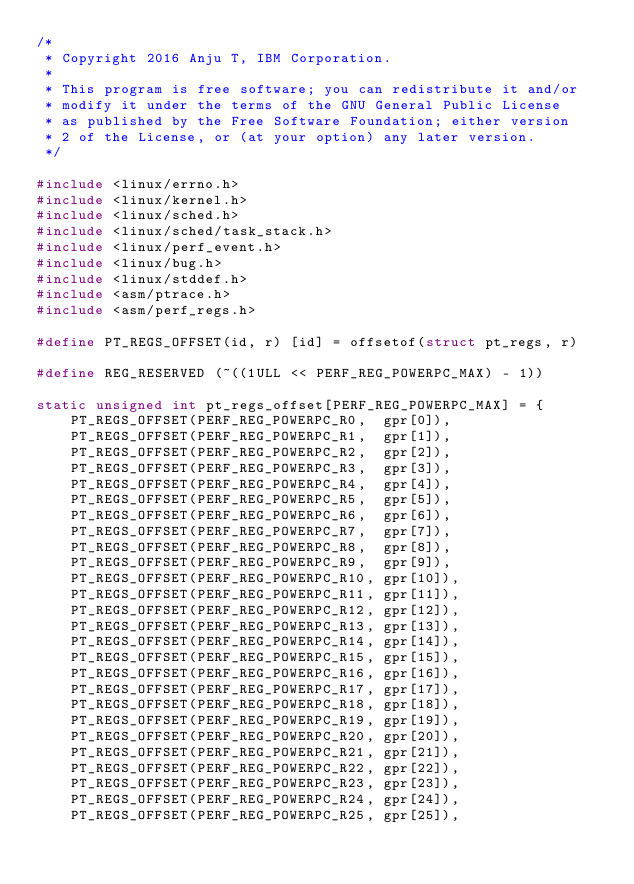Convert code to text. <code><loc_0><loc_0><loc_500><loc_500><_C_>/*
 * Copyright 2016 Anju T, IBM Corporation.
 *
 * This program is free software; you can redistribute it and/or
 * modify it under the terms of the GNU General Public License
 * as published by the Free Software Foundation; either version
 * 2 of the License, or (at your option) any later version.
 */

#include <linux/errno.h>
#include <linux/kernel.h>
#include <linux/sched.h>
#include <linux/sched/task_stack.h>
#include <linux/perf_event.h>
#include <linux/bug.h>
#include <linux/stddef.h>
#include <asm/ptrace.h>
#include <asm/perf_regs.h>

#define PT_REGS_OFFSET(id, r) [id] = offsetof(struct pt_regs, r)

#define REG_RESERVED (~((1ULL << PERF_REG_POWERPC_MAX) - 1))

static unsigned int pt_regs_offset[PERF_REG_POWERPC_MAX] = {
	PT_REGS_OFFSET(PERF_REG_POWERPC_R0,  gpr[0]),
	PT_REGS_OFFSET(PERF_REG_POWERPC_R1,  gpr[1]),
	PT_REGS_OFFSET(PERF_REG_POWERPC_R2,  gpr[2]),
	PT_REGS_OFFSET(PERF_REG_POWERPC_R3,  gpr[3]),
	PT_REGS_OFFSET(PERF_REG_POWERPC_R4,  gpr[4]),
	PT_REGS_OFFSET(PERF_REG_POWERPC_R5,  gpr[5]),
	PT_REGS_OFFSET(PERF_REG_POWERPC_R6,  gpr[6]),
	PT_REGS_OFFSET(PERF_REG_POWERPC_R7,  gpr[7]),
	PT_REGS_OFFSET(PERF_REG_POWERPC_R8,  gpr[8]),
	PT_REGS_OFFSET(PERF_REG_POWERPC_R9,  gpr[9]),
	PT_REGS_OFFSET(PERF_REG_POWERPC_R10, gpr[10]),
	PT_REGS_OFFSET(PERF_REG_POWERPC_R11, gpr[11]),
	PT_REGS_OFFSET(PERF_REG_POWERPC_R12, gpr[12]),
	PT_REGS_OFFSET(PERF_REG_POWERPC_R13, gpr[13]),
	PT_REGS_OFFSET(PERF_REG_POWERPC_R14, gpr[14]),
	PT_REGS_OFFSET(PERF_REG_POWERPC_R15, gpr[15]),
	PT_REGS_OFFSET(PERF_REG_POWERPC_R16, gpr[16]),
	PT_REGS_OFFSET(PERF_REG_POWERPC_R17, gpr[17]),
	PT_REGS_OFFSET(PERF_REG_POWERPC_R18, gpr[18]),
	PT_REGS_OFFSET(PERF_REG_POWERPC_R19, gpr[19]),
	PT_REGS_OFFSET(PERF_REG_POWERPC_R20, gpr[20]),
	PT_REGS_OFFSET(PERF_REG_POWERPC_R21, gpr[21]),
	PT_REGS_OFFSET(PERF_REG_POWERPC_R22, gpr[22]),
	PT_REGS_OFFSET(PERF_REG_POWERPC_R23, gpr[23]),
	PT_REGS_OFFSET(PERF_REG_POWERPC_R24, gpr[24]),
	PT_REGS_OFFSET(PERF_REG_POWERPC_R25, gpr[25]),</code> 